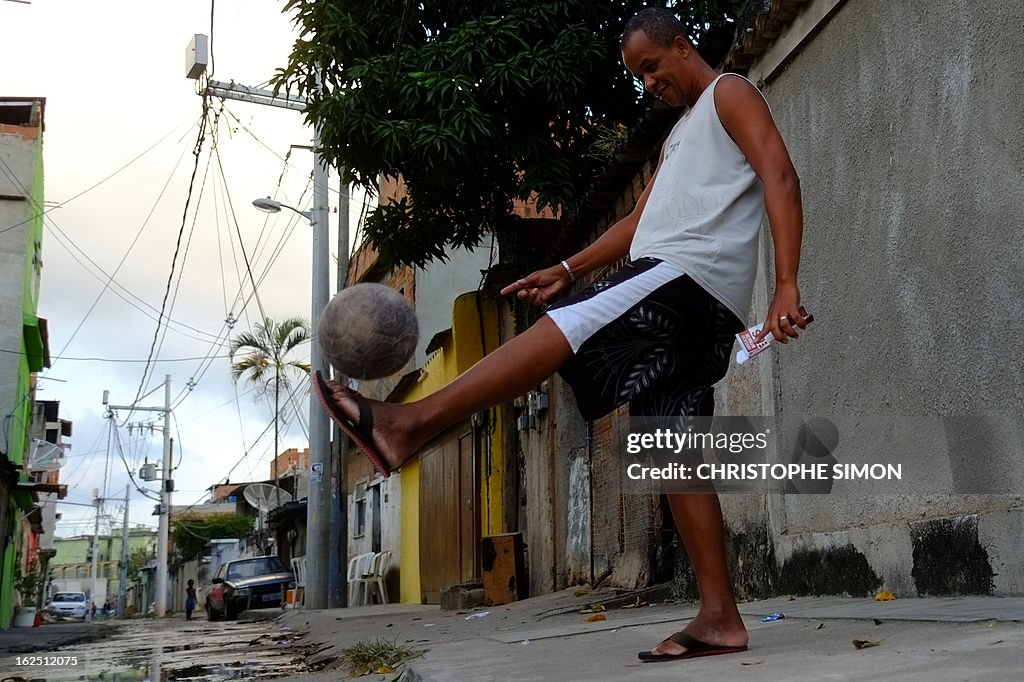What does this scene reveal about the cultural or local significance of soccer in this community? The image captures a person engaging in a casual game of street soccer, evident from the urban backdrop and informal footwear. This setting suggests that soccer plays a vital role as a social activity, bringing community members together regardless of circumstances. The sport is likely embraced as accessible entertainment and a form of physical exercise, woven into the communal lifestyle and enjoyed across ages. 